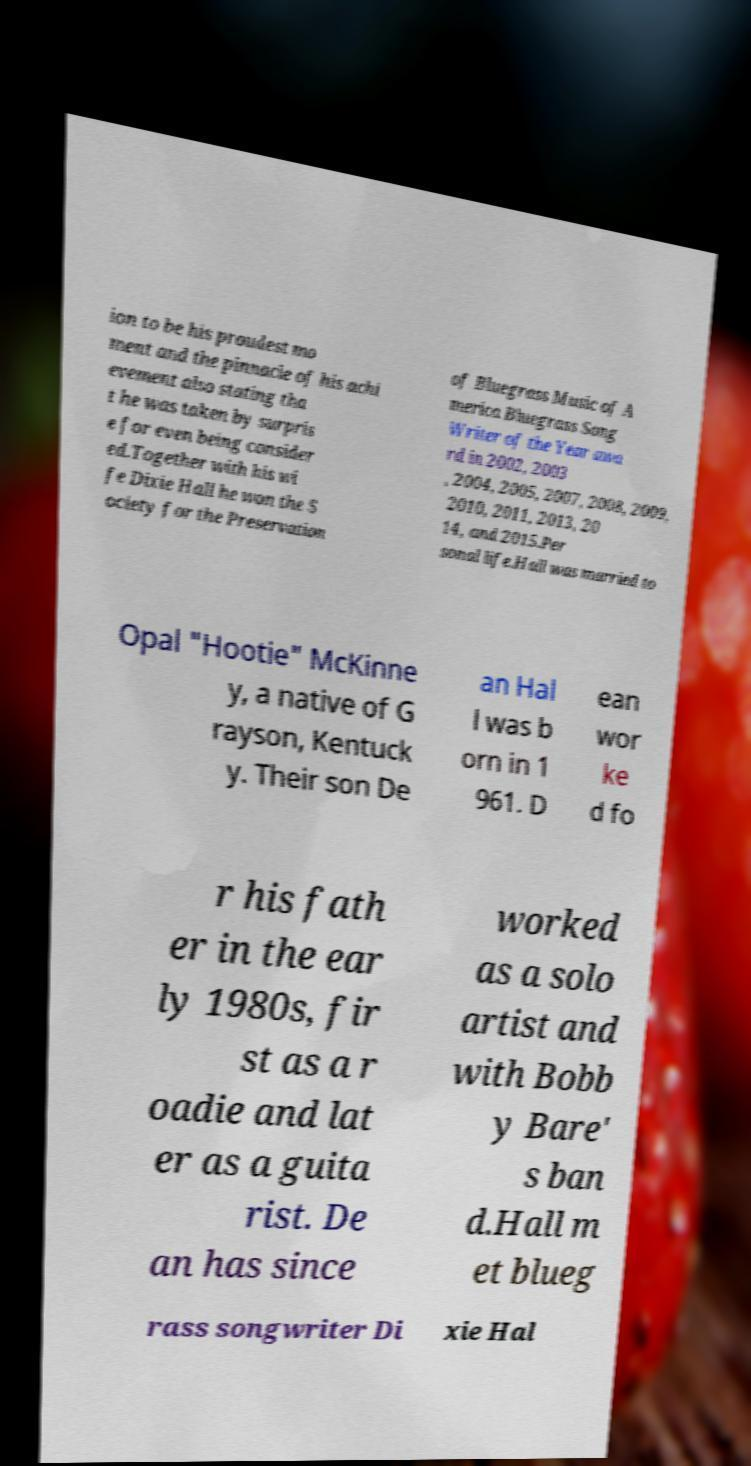Could you extract and type out the text from this image? ion to be his proudest mo ment and the pinnacle of his achi evement also stating tha t he was taken by surpris e for even being consider ed.Together with his wi fe Dixie Hall he won the S ociety for the Preservation of Bluegrass Music of A merica Bluegrass Song Writer of the Year awa rd in 2002, 2003 , 2004, 2005, 2007, 2008, 2009, 2010, 2011, 2013, 20 14, and 2015.Per sonal life.Hall was married to Opal "Hootie" McKinne y, a native of G rayson, Kentuck y. Their son De an Hal l was b orn in 1 961. D ean wor ke d fo r his fath er in the ear ly 1980s, fir st as a r oadie and lat er as a guita rist. De an has since worked as a solo artist and with Bobb y Bare' s ban d.Hall m et blueg rass songwriter Di xie Hal 